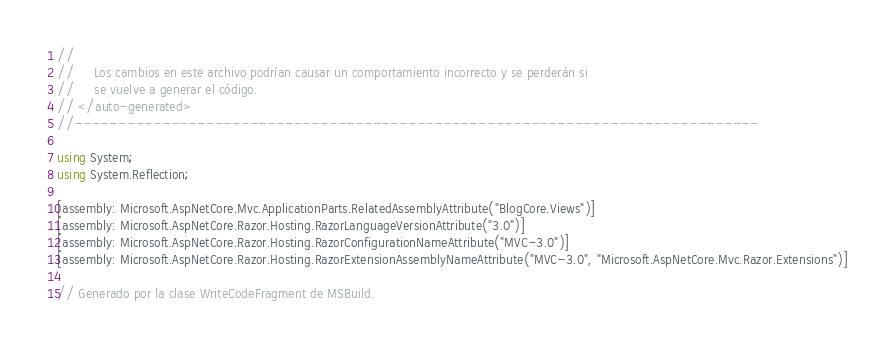<code> <loc_0><loc_0><loc_500><loc_500><_C#_>//
//     Los cambios en este archivo podrían causar un comportamiento incorrecto y se perderán si
//     se vuelve a generar el código.
// </auto-generated>
//------------------------------------------------------------------------------

using System;
using System.Reflection;

[assembly: Microsoft.AspNetCore.Mvc.ApplicationParts.RelatedAssemblyAttribute("BlogCore.Views")]
[assembly: Microsoft.AspNetCore.Razor.Hosting.RazorLanguageVersionAttribute("3.0")]
[assembly: Microsoft.AspNetCore.Razor.Hosting.RazorConfigurationNameAttribute("MVC-3.0")]
[assembly: Microsoft.AspNetCore.Razor.Hosting.RazorExtensionAssemblyNameAttribute("MVC-3.0", "Microsoft.AspNetCore.Mvc.Razor.Extensions")]

// Generado por la clase WriteCodeFragment de MSBuild.

</code> 